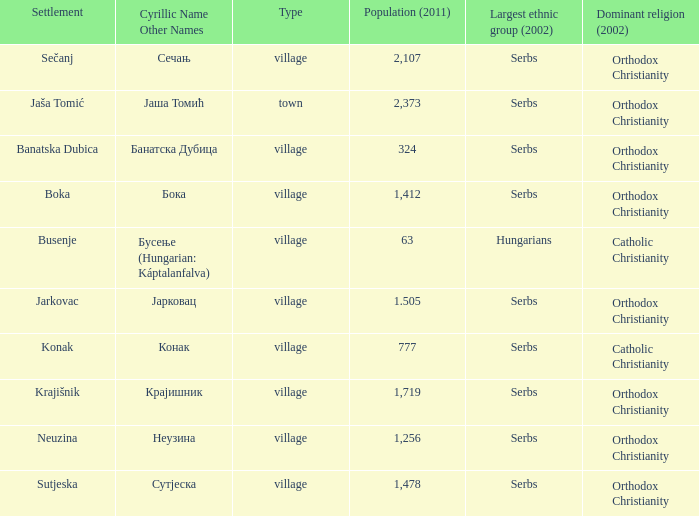Would you be able to parse every entry in this table? {'header': ['Settlement', 'Cyrillic Name Other Names', 'Type', 'Population (2011)', 'Largest ethnic group (2002)', 'Dominant religion (2002)'], 'rows': [['Sečanj', 'Сечањ', 'village', '2,107', 'Serbs', 'Orthodox Christianity'], ['Jaša Tomić', 'Јаша Томић', 'town', '2,373', 'Serbs', 'Orthodox Christianity'], ['Banatska Dubica', 'Банатска Дубица', 'village', '324', 'Serbs', 'Orthodox Christianity'], ['Boka', 'Бока', 'village', '1,412', 'Serbs', 'Orthodox Christianity'], ['Busenje', 'Бусење (Hungarian: Káptalanfalva)', 'village', '63', 'Hungarians', 'Catholic Christianity'], ['Jarkovac', 'Јарковац', 'village', '1.505', 'Serbs', 'Orthodox Christianity'], ['Konak', 'Конак', 'village', '777', 'Serbs', 'Catholic Christianity'], ['Krajišnik', 'Крајишник', 'village', '1,719', 'Serbs', 'Orthodox Christianity'], ['Neuzina', 'Неузина', 'village', '1,256', 'Serbs', 'Orthodox Christianity'], ['Sutjeska', 'Сутјеска', 'village', '1,478', 'Serbs', 'Orthodox Christianity']]} What kind of type is  бока? Village. 